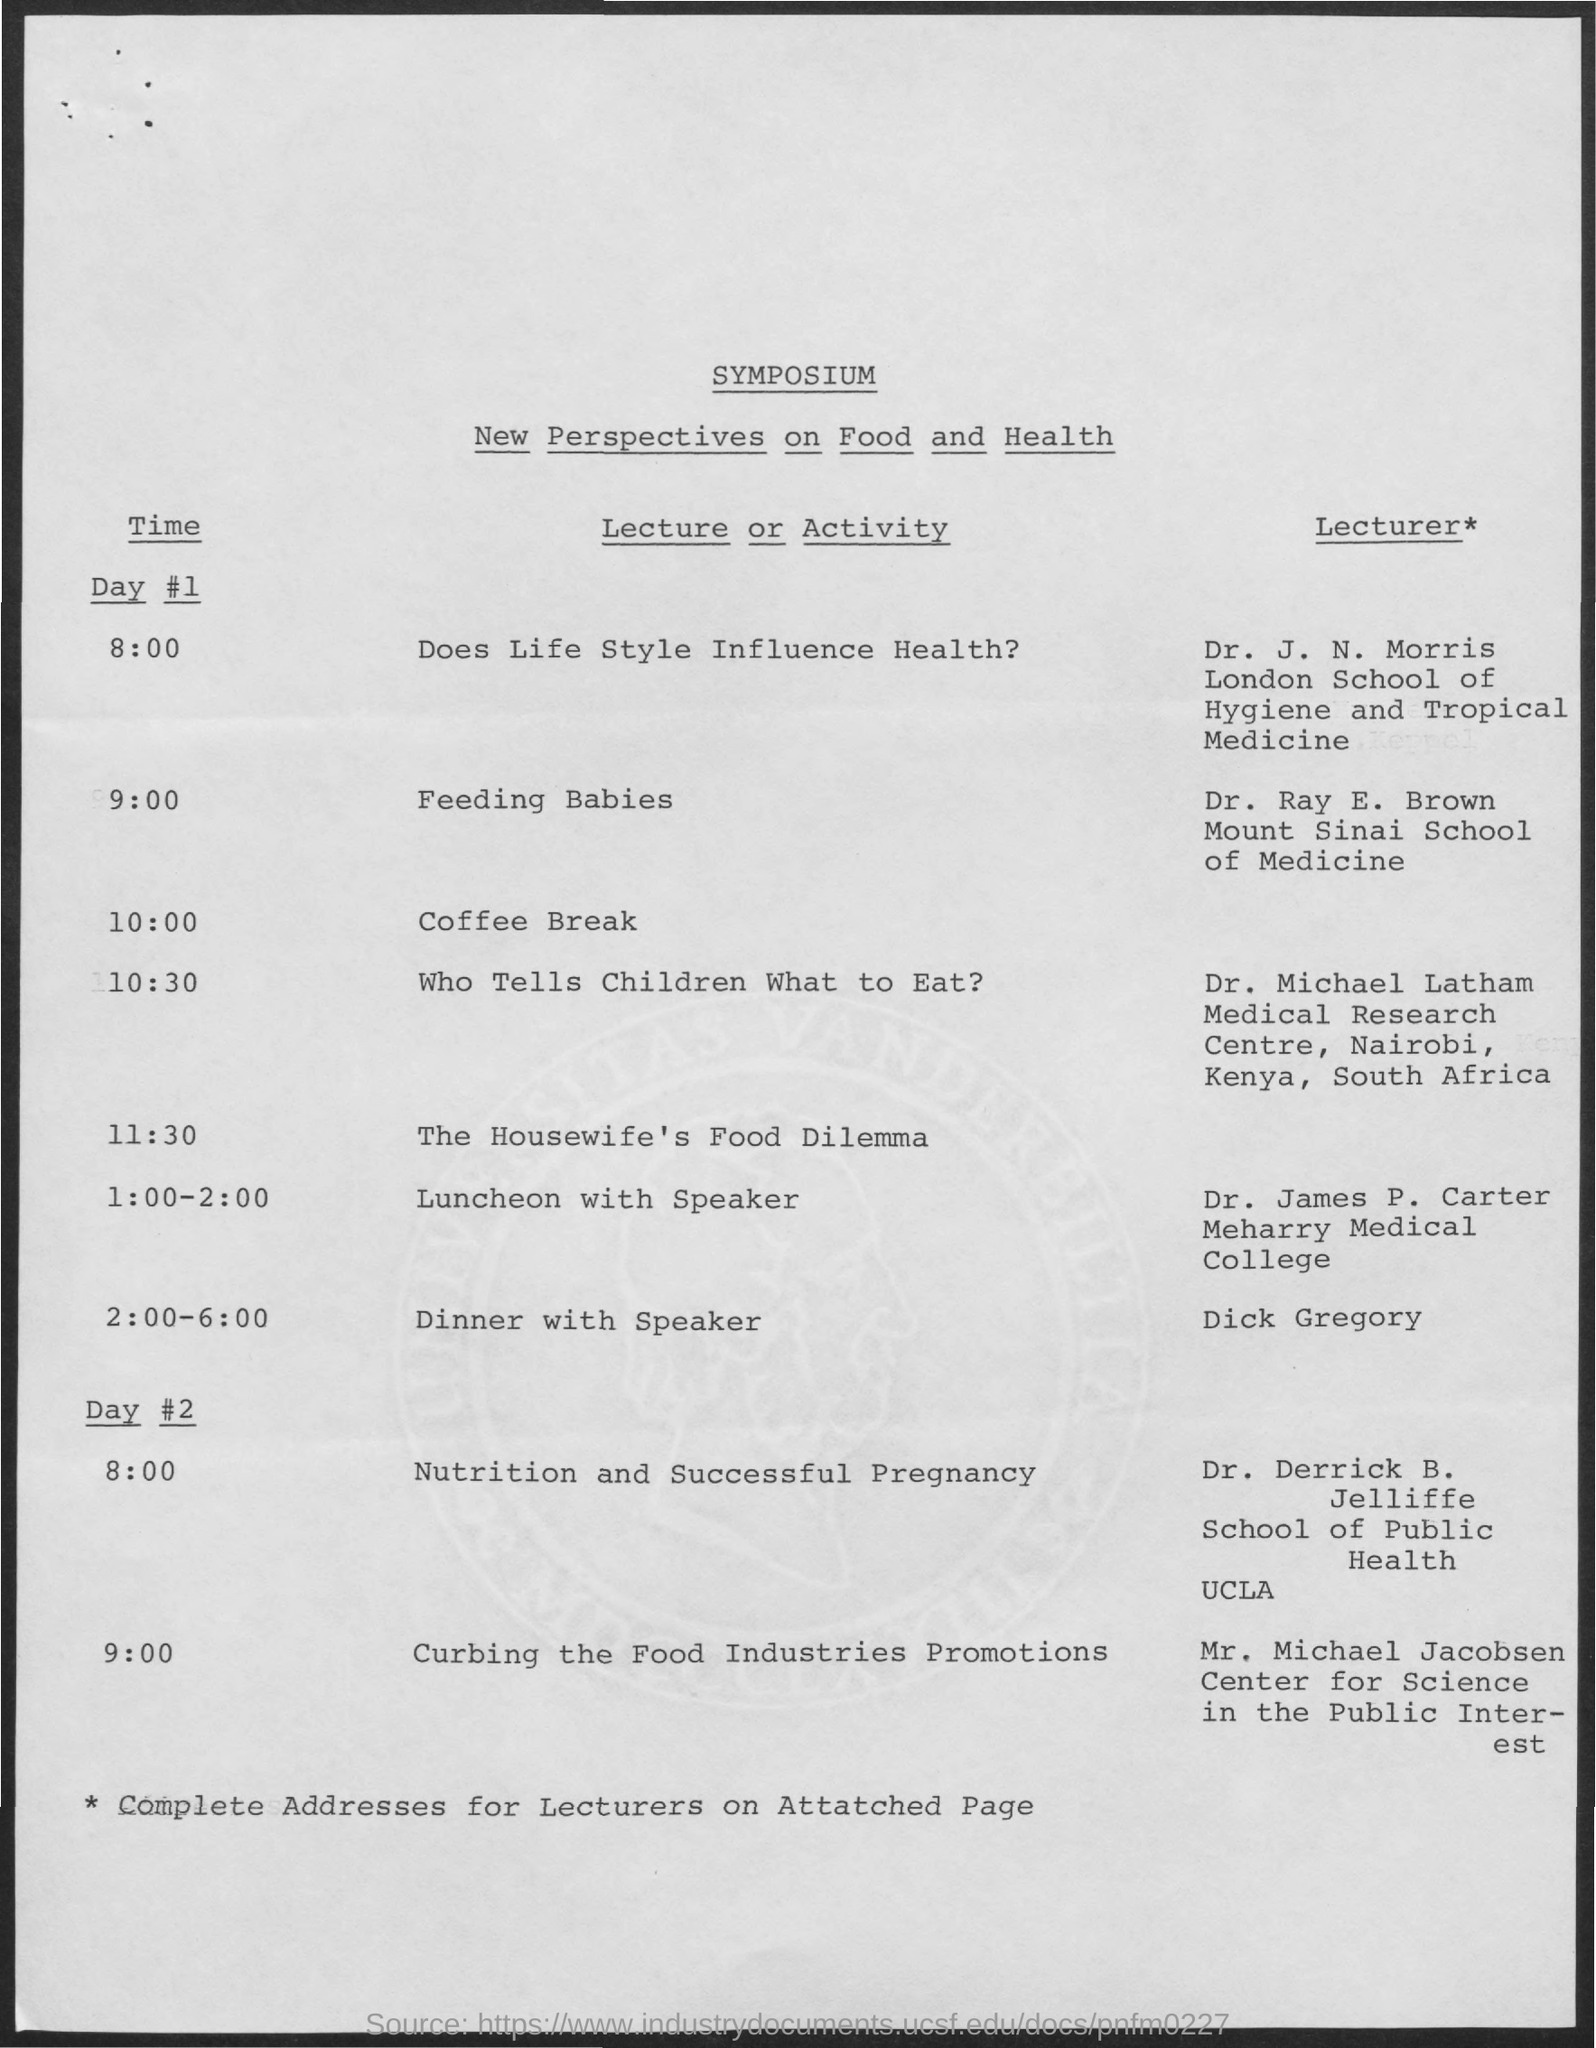Indicate a few pertinent items in this graphic. At 11:30 on day #1, the activity that occurred was named 'The Housewife's Food Dilemma.' The activity at the time of 1:00-2:00 on day#1 is a luncheon with a speaker. At the time of 8:00 on day #1, the activity level is unknown. The influence of lifestyle on health is a topic of debate and discussion. At the time of 2:00-6:00 on day #1, dinner was being had with the speaker. Curbing the food industry's promotions at 9:00 on day #2 is the name of the activity. 